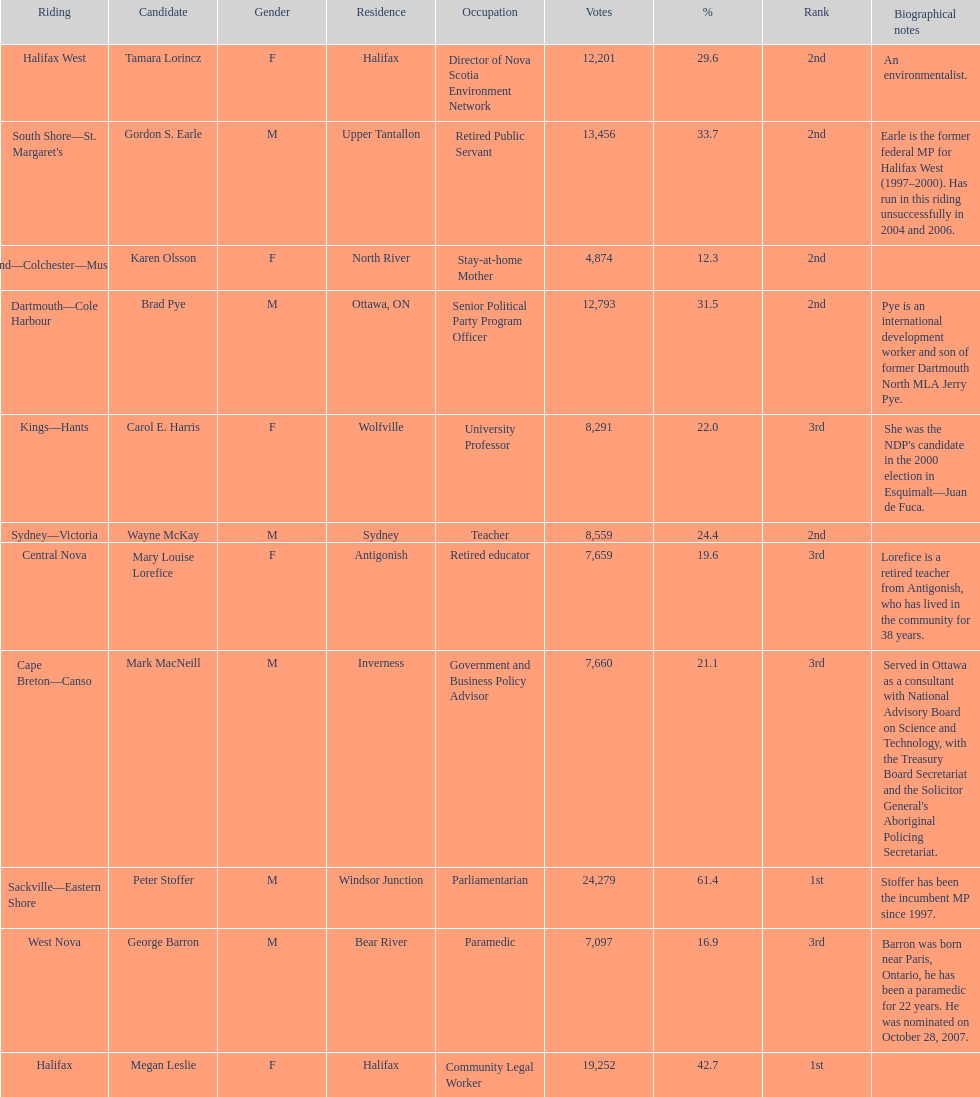What is the first riding? Cape Breton-Canso. 